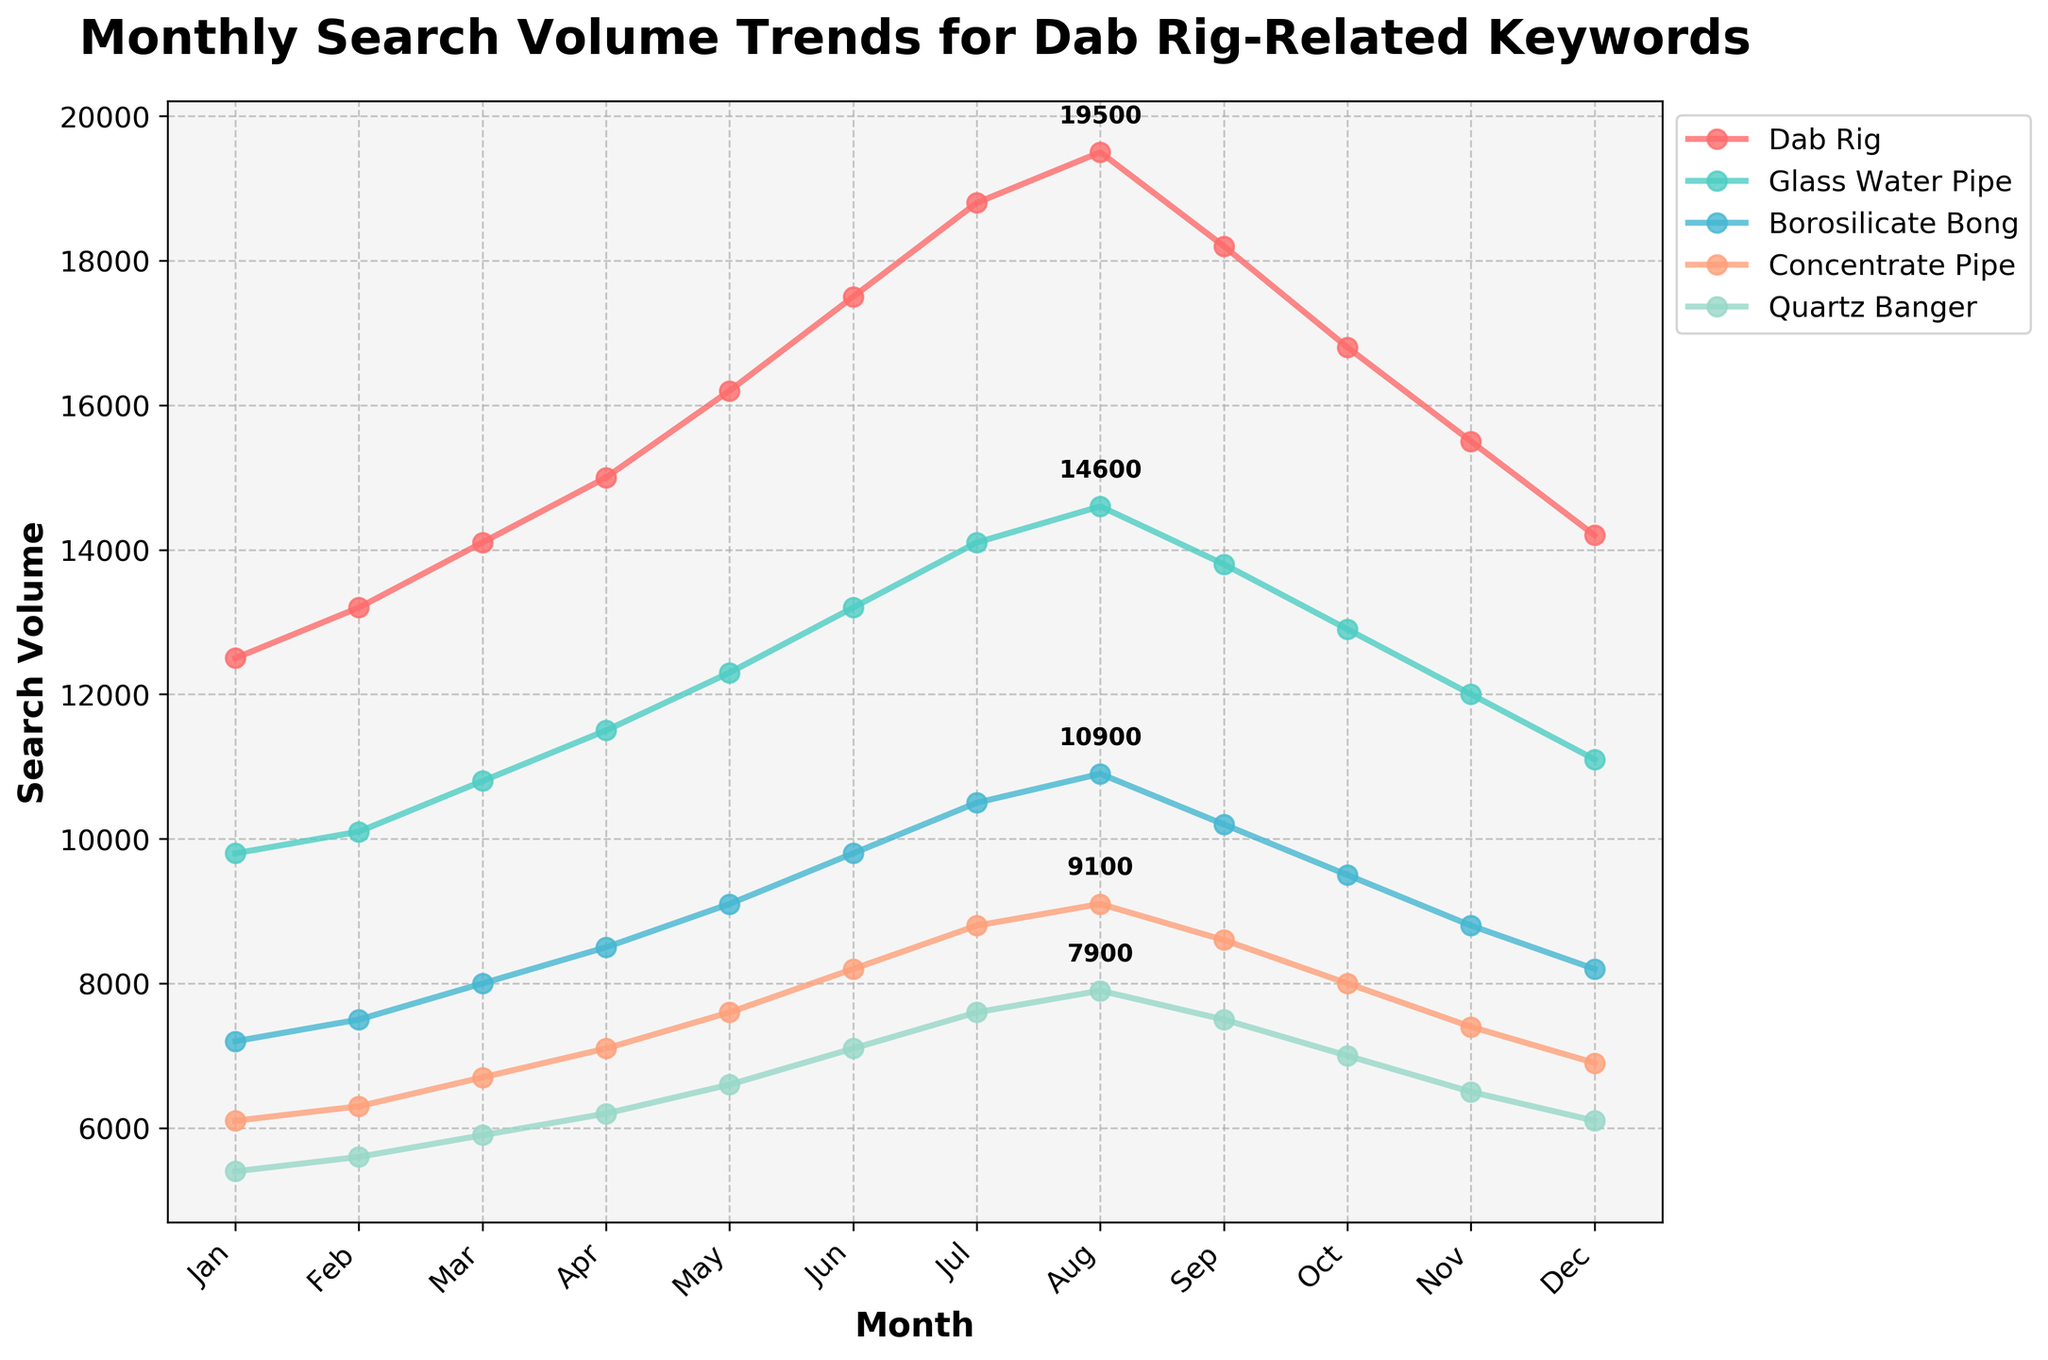What's the keyword with the highest search volume in July? The keyword 'Dab Rig' has the highest search volume in July with 18,800 searches. You can see this by looking at the peak values for July.
Answer: Dab Rig Which keyword had the most consistent growth over the months? By visually observing the lines, 'Dab Rig' shows the most consistent growth with a continuous upward trend from January to August.
Answer: Dab Rig Which month had the highest total search volume for all keywords combined? Sum the search volumes for each keyword across all months. The formula for each month: Total = Dab Rig + Glass Water Pipe + Borosilicate Bong + Concentrate Pipe + Quartz Banger. The highest total is observed in August with 19500 + 14600 + 10900 + 9100 + 7900 = 62000.
Answer: August Is the search volume for 'Quartz Banger' ever higher than 'Glass Water Pipe'? Comparing each month's search volume for these keywords shows that 'Quartz Banger' is always lower than 'Glass Water Pipe'.
Answer: No Which keyword shows the most significant decline after July? From July to December, 'Glass Water Pipe' drops from 14100 to 11100, a difference of 3000. The other keywords show smaller declines or similar trends.
Answer: Glass Water Pipe How much did the 'Concentrate Pipe' search volume increase from January to its peak? 'Concentrate Pipe' has its peak in July with 8800 searches. The increase from January's 6100 is calculated as 8800 - 6100 = 2700.
Answer: 2700 What was the average search volume for 'Borosilicate Bong' across the year? Sum the monthly search volumes for 'Borosilicate Bong' (7200 + 7500 + 8000 + 8500 + 9100 + 9800 + 10500 + 10900 + 10200 + 9500 + 8800 + 8200 = 108200) and divide by 12 months. 108200 / 12 = 9016.67.
Answer: 9016.67 